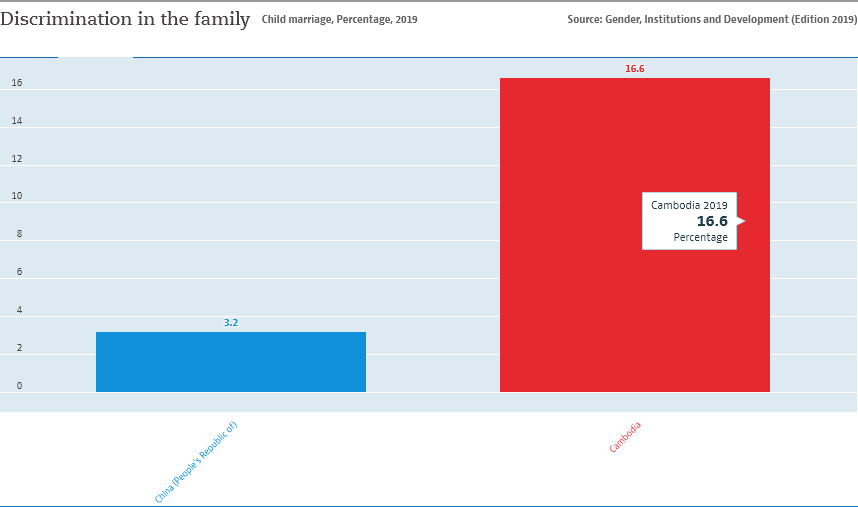List a handful of essential elements in this visual. The value of the red bar is 16.6... The value of the smallest bar is not equal to 1/5th the value of the largest bar. 